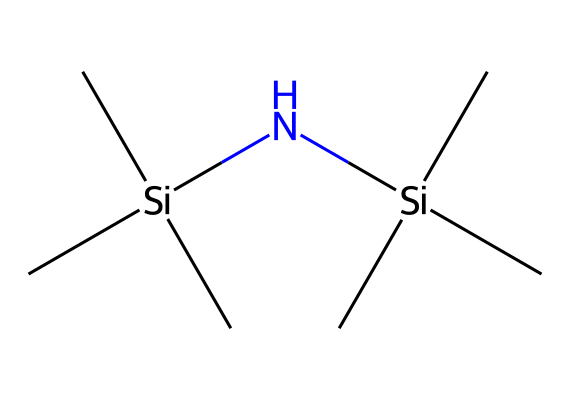What is the total number of silicon atoms in hexamethyldisilazane? By examining the structure, we see two silicon atoms present. Each silicon atom is bonded to three methyl (CH3) groups and one nitrogen (N) atom.
Answer: two How many nitrogen atoms are in hexamethyldisilazane? In the given structure, there is one nitrogen atom present, which is bonded to one of the silicon atoms.
Answer: one What is the primary use of hexamethyldisilazane? Hexamethyldisilazane is primarily used as a silylating agent in surface treatments and semiconductor manufacturing.
Answer: silylating agent What is the molecular formula of hexamethyldisilazane? From the structure, we can deduce the molecular formula by counting the atoms: there are two silicon (Si), one nitrogen (N), and six carbon (C) atoms; thus, the formula is Si2C6H21N.
Answer: Si2C6H21N What type of functional group is present in hexamethyldisilazane? The presence of the silicon-nitrogen bond indicates that this compound features an organosilicon functional group specifically bonded to a nitrogen atom, characteristic of silylating agents.
Answer: organosilicon 